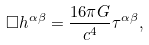Convert formula to latex. <formula><loc_0><loc_0><loc_500><loc_500>\Box h ^ { \alpha \beta } = \frac { 1 6 \pi G } { c ^ { 4 } } \tau ^ { \alpha \beta } ,</formula> 